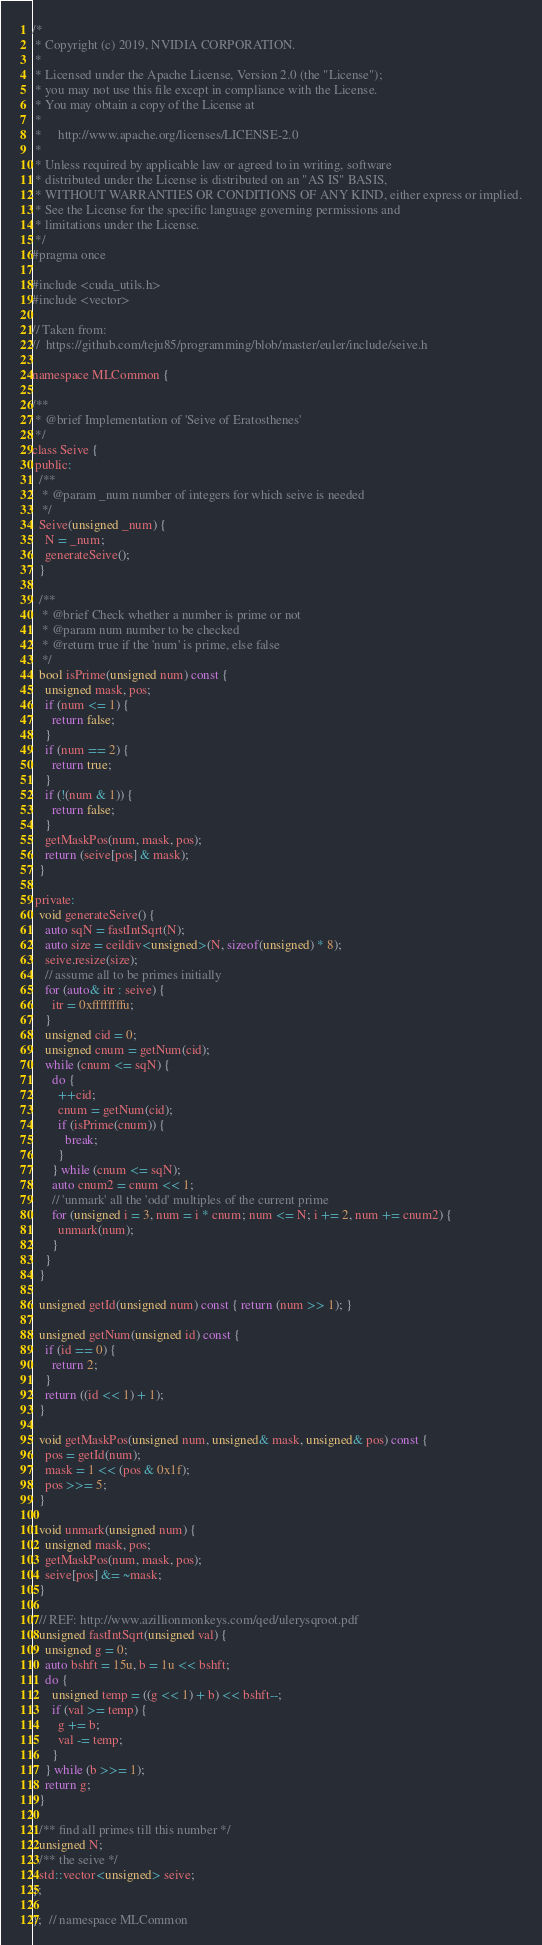Convert code to text. <code><loc_0><loc_0><loc_500><loc_500><_Cuda_>/*
 * Copyright (c) 2019, NVIDIA CORPORATION.
 *
 * Licensed under the Apache License, Version 2.0 (the "License");
 * you may not use this file except in compliance with the License.
 * You may obtain a copy of the License at
 *
 *     http://www.apache.org/licenses/LICENSE-2.0
 *
 * Unless required by applicable law or agreed to in writing, software
 * distributed under the License is distributed on an "AS IS" BASIS,
 * WITHOUT WARRANTIES OR CONDITIONS OF ANY KIND, either express or implied.
 * See the License for the specific language governing permissions and
 * limitations under the License.
 */
#pragma once

#include <cuda_utils.h>
#include <vector>

// Taken from:
//  https://github.com/teju85/programming/blob/master/euler/include/seive.h

namespace MLCommon {

/**
 * @brief Implementation of 'Seive of Eratosthenes'
 */
class Seive {
 public:
  /**
   * @param _num number of integers for which seive is needed
   */
  Seive(unsigned _num) {
    N = _num;
    generateSeive();
  }

  /**
   * @brief Check whether a number is prime or not
   * @param num number to be checked
   * @return true if the 'num' is prime, else false
   */
  bool isPrime(unsigned num) const {
    unsigned mask, pos;
    if (num <= 1) {
      return false;
    }
    if (num == 2) {
      return true;
    }
    if (!(num & 1)) {
      return false;
    }
    getMaskPos(num, mask, pos);
    return (seive[pos] & mask);
  }

 private:
  void generateSeive() {
    auto sqN = fastIntSqrt(N);
    auto size = ceildiv<unsigned>(N, sizeof(unsigned) * 8);
    seive.resize(size);
    // assume all to be primes initially
    for (auto& itr : seive) {
      itr = 0xffffffffu;
    }
    unsigned cid = 0;
    unsigned cnum = getNum(cid);
    while (cnum <= sqN) {
      do {
        ++cid;
        cnum = getNum(cid);
        if (isPrime(cnum)) {
          break;
        }
      } while (cnum <= sqN);
      auto cnum2 = cnum << 1;
      // 'unmark' all the 'odd' multiples of the current prime
      for (unsigned i = 3, num = i * cnum; num <= N; i += 2, num += cnum2) {
        unmark(num);
      }
    }
  }

  unsigned getId(unsigned num) const { return (num >> 1); }

  unsigned getNum(unsigned id) const {
    if (id == 0) {
      return 2;
    }
    return ((id << 1) + 1);
  }

  void getMaskPos(unsigned num, unsigned& mask, unsigned& pos) const {
    pos = getId(num);
    mask = 1 << (pos & 0x1f);
    pos >>= 5;
  }

  void unmark(unsigned num) {
    unsigned mask, pos;
    getMaskPos(num, mask, pos);
    seive[pos] &= ~mask;
  }

  // REF: http://www.azillionmonkeys.com/qed/ulerysqroot.pdf
  unsigned fastIntSqrt(unsigned val) {
    unsigned g = 0;
    auto bshft = 15u, b = 1u << bshft;
    do {
      unsigned temp = ((g << 1) + b) << bshft--;
      if (val >= temp) {
        g += b;
        val -= temp;
      }
    } while (b >>= 1);
    return g;
  }

  /** find all primes till this number */
  unsigned N;
  /** the seive */
  std::vector<unsigned> seive;
};

};  // namespace MLCommon
</code> 